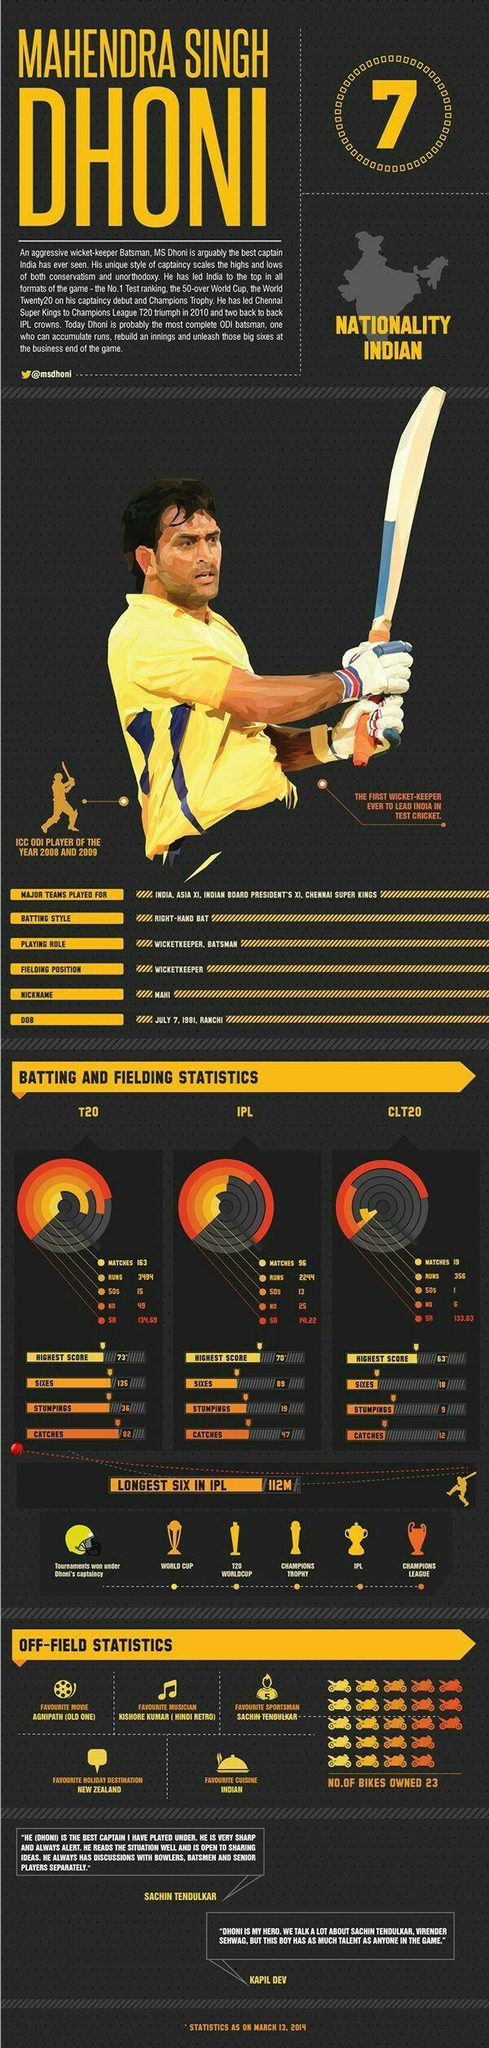Specify some key components in this picture. M.S. Dhoni has scored the highest IPL score of 70* in the year 2014, as of March 13th. The strike rate of M.S. Dhoni in T20 matches as of March 13, 2014 was 134.69. As of March 13, 2014, M.S. Dhoni had taken a total of 12 catches in the Champions League Twenty20 (CLT20) matches. As of March 13, 2014, the strike rate of M.S. Dhoni in IPL games is 141.22. As of March 13, 2014, M.S. Dhoni had scored a total of 50 runs in the CLT20 tournament. 